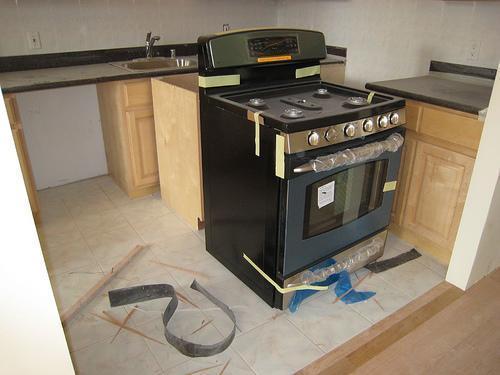How many men are wearing white in the image?
Give a very brief answer. 0. 